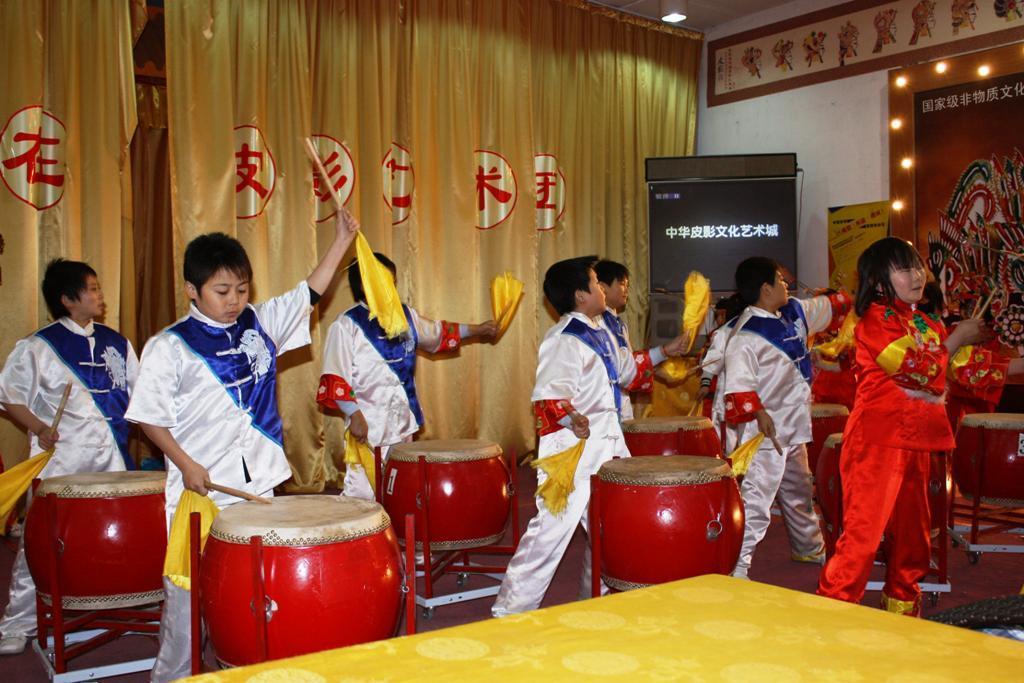In one or two sentences, can you explain what this image depicts? in this picture there are group of people who are playing musical instrument and holding a yellow cloth in their hands. There is a yellow curtain, some lights , and screen at the background. There is a yellow curtain. 